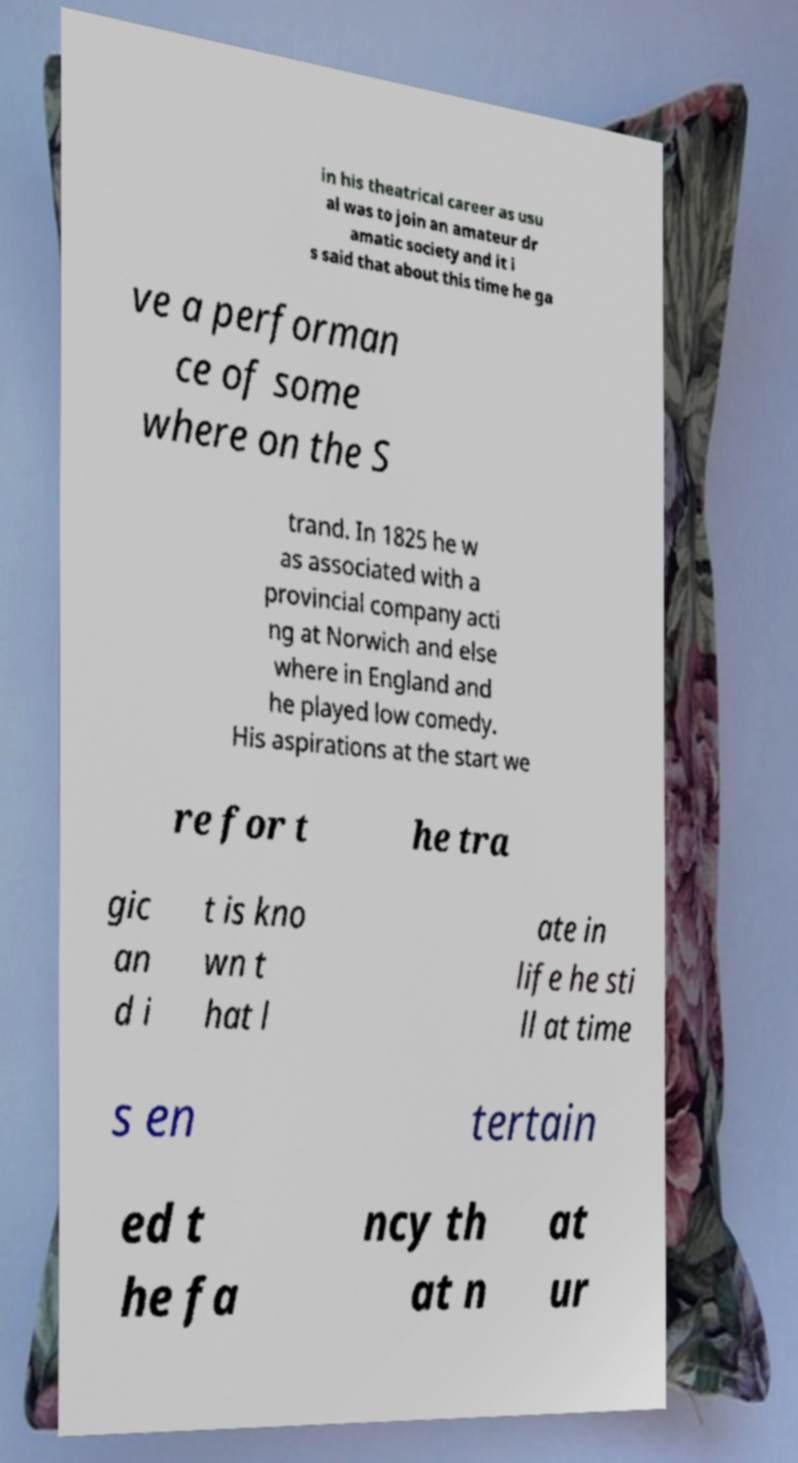There's text embedded in this image that I need extracted. Can you transcribe it verbatim? in his theatrical career as usu al was to join an amateur dr amatic society and it i s said that about this time he ga ve a performan ce of some where on the S trand. In 1825 he w as associated with a provincial company acti ng at Norwich and else where in England and he played low comedy. His aspirations at the start we re for t he tra gic an d i t is kno wn t hat l ate in life he sti ll at time s en tertain ed t he fa ncy th at n at ur 